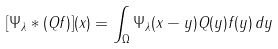Convert formula to latex. <formula><loc_0><loc_0><loc_500><loc_500>[ \Psi _ { \lambda } \ast ( Q f ) ] ( x ) = \int _ { \Omega } \Psi _ { \lambda } ( x - y ) Q ( y ) f ( y ) \, d y</formula> 